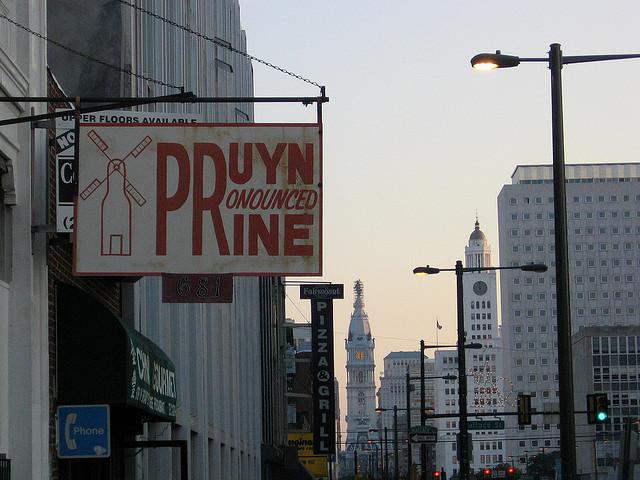What tower is shown in the background?
Quick response, please. Church. What color is the lights?
Concise answer only. White. Can you smoke here?
Be succinct. Yes. What object is pictured next to the text?
Keep it brief. Windmill. What color is the traffic light on the right displaying?
Quick response, please. Green. What hotel/motel sign can be seen in the background?
Give a very brief answer. None. What store is in the background?
Be succinct. Pizza. What does the red sign say?
Write a very short answer. Pruyn pronounced prine. What do the red and white signs read?
Answer briefly. Pruyn pronounced prine. What color of the sky?
Write a very short answer. Gray. Is the street light on?
Write a very short answer. Yes. What does the sign say?
Quick response, please. Pruyn pronounced prine. Where is this located?
Be succinct. City. What flowers are in the planters?
Quick response, please. None. What does the white and black sign on the building say?
Answer briefly. Pizza grill. How many floors are on the building to the right?
Answer briefly. 20. What colors are on the sign?
Be succinct. Red and white. What color is the light?
Quick response, please. Green. What country is written on the sign?
Concise answer only. Pruyn. How many different buildings are in the background?
Keep it brief. 8. Whose market is it?
Keep it brief. Pruyn. 